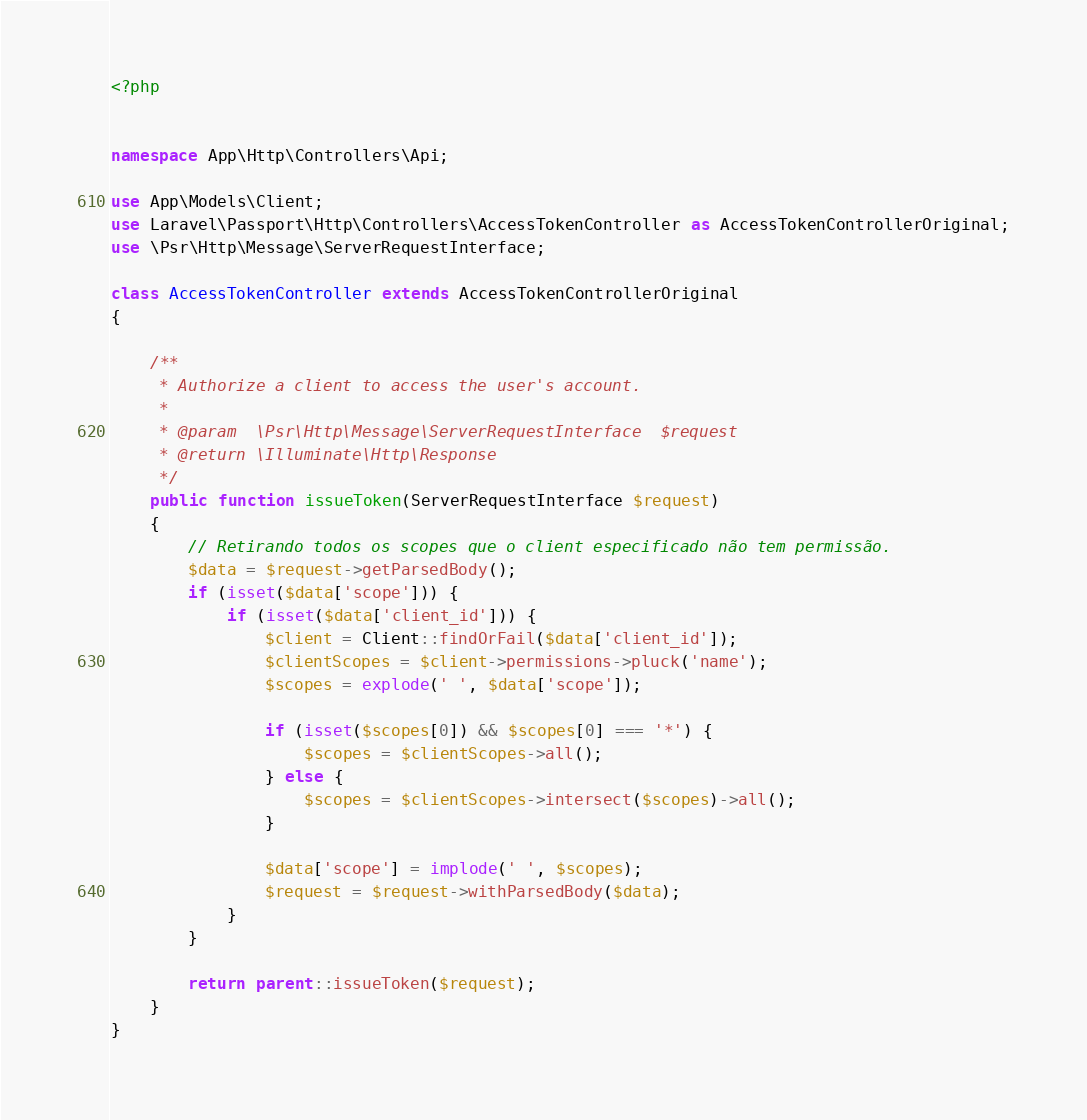<code> <loc_0><loc_0><loc_500><loc_500><_PHP_><?php


namespace App\Http\Controllers\Api;

use App\Models\Client;
use Laravel\Passport\Http\Controllers\AccessTokenController as AccessTokenControllerOriginal;
use \Psr\Http\Message\ServerRequestInterface;

class AccessTokenController extends AccessTokenControllerOriginal
{

    /**
     * Authorize a client to access the user's account.
     *
     * @param  \Psr\Http\Message\ServerRequestInterface  $request
     * @return \Illuminate\Http\Response
     */
    public function issueToken(ServerRequestInterface $request)
    {
        // Retirando todos os scopes que o client especificado não tem permissão.
        $data = $request->getParsedBody();
        if (isset($data['scope'])) {
            if (isset($data['client_id'])) {
                $client = Client::findOrFail($data['client_id']);
                $clientScopes = $client->permissions->pluck('name');
                $scopes = explode(' ', $data['scope']);

                if (isset($scopes[0]) && $scopes[0] === '*') {
                    $scopes = $clientScopes->all();
                } else {
                    $scopes = $clientScopes->intersect($scopes)->all();
                }

                $data['scope'] = implode(' ', $scopes);
                $request = $request->withParsedBody($data);
            }
        }

        return parent::issueToken($request);
    }
}
</code> 